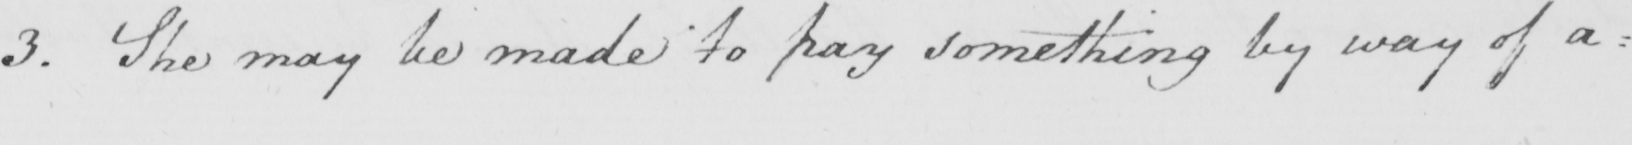What is written in this line of handwriting? 3 . She may be made to pay something by way of a= 